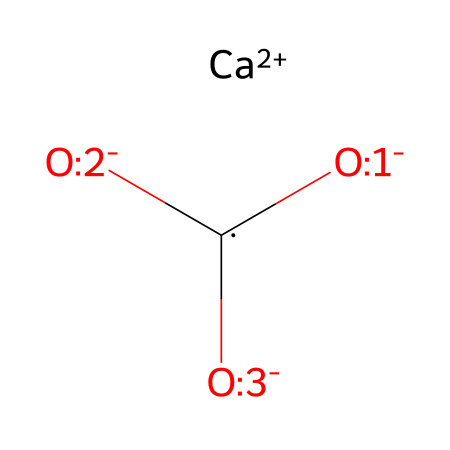What is the chemical name represented by the SMILES? The SMILES notation represents calcium carbonate, which consists of calcium ions and carbonate ions combined in a specific ratio.
Answer: calcium carbonate How many oxygen atoms are present in the structure? Analyzing the SMILES, we can see that there are three oxygen atoms connected to the carbonate group indicated by the three O in the formula.
Answer: three What is the charge of the calcium ion in this structure? The notation [Ca+2] indicates that the calcium ion carries a positive charge of +2, which is important for its role in balancing the negative charges of the carbonate ions.
Answer: +2 What does the presence of the carbonate ion suggest about the properties of limestone? The carbonate ion structure is indicative of the carbonate minerals and suggests that limestone has properties related to reactivity with acids, which is a characteristic feature of calcium carbonate-based rocks.
Answer: reactivity with acids Which type of electrolyte is represented by this chemical structure? Since calcium carbonate can dissociate in water, leading to the release of calcium and carbonate ions, it is classified as a weak electrolyte.
Answer: weak electrolyte What is the significance of the calcium-to-carbonate ratio in limestone? The calcium-to-carbonate ratio informs us about the stoichiometry of the compound, indicating a one-to-one ratio, which is essential for the stability and formation of the limestone rock structure.
Answer: one-to-one ratio 